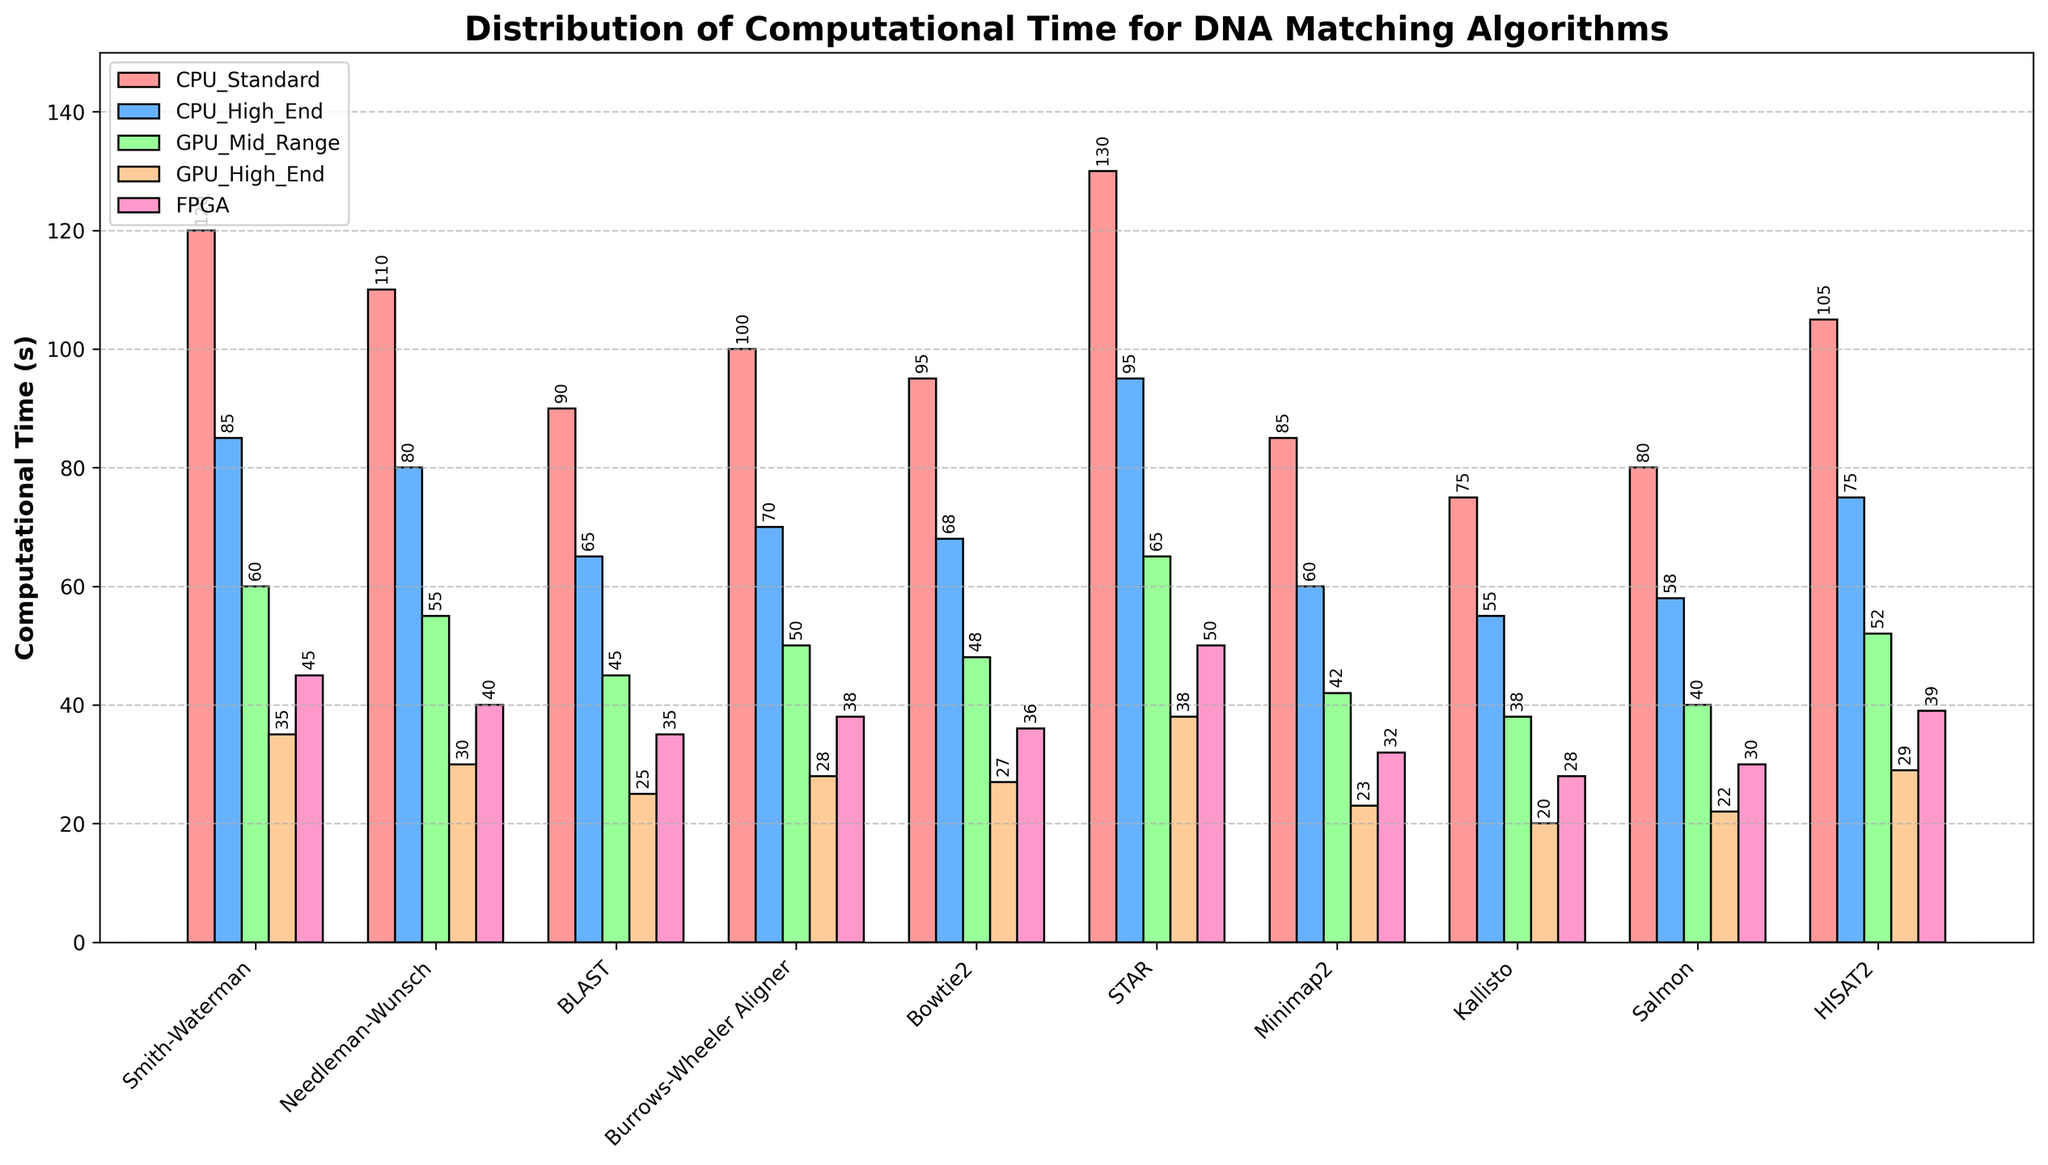Which algorithm has the highest computational time on GPU High-End hardware? By comparing the height of the bars for GPU High-End across all algorithms, we see that STAR has the tallest bar.
Answer: STAR Which algorithm shows the largest difference in computational time between CPU Standard and GPU High-End? By calculating the difference for each algorithm, the largest difference is with Smith-Waterman, which is 120 - 35 = 85 seconds.
Answer: Smith-Waterman What is the average computational time for BLAST across all hardware configurations? Sum the computational times for BLAST on all hardware (90 + 65 + 45 + 25 + 35) and divide by 5. The sum is 260, so the average is 260/5 = 52.
Answer: 52 What is the total computational time for the STAR algorithm on CPU High-End and FPGA? Sum the times on CPU High-End and FPGA for STAR: 95 + 50 = 145.
Answer: 145 Which combination of algorithm and hardware shows the lowest computational time? By locating the shortest bar across all algorithms and hardware, it is Kallisto on GPU High-End with a value of 20 seconds.
Answer: Kallisto on GPU High-End Which algorithm has less computational time on FPGA compared to CPU High-End? Compare the heights of the bars for FPGA and CPU High-End, observing which algorithms have taller bars for CPU High-End. These are Smith-Waterman, Needleman-Wunsch, Burrows-Wheeler Aligner, Bowtie2, Minimap2, Kallisto, Salmon, and HISAT2.
Answer: Smith-Waterman, Needleman-Wunsch, Burrows-Wheeler Aligner, Bowtie2, Minimap2, Kallisto, Salmon, HISAT2 How does the computational time of Minimap2 on GPU Mid-Range compare to BLAST on the same hardware? Compare the heights of the bars for Minimap2 and BLAST on GPU Mid-Range. Minimap2 has a value of 42 seconds and BLAST has 45 seconds. Minimap2 is less.
Answer: Minimap2 is less What is the difference in computational time between the highest and lowest values for Bowtie2 across hardware configurations? Identify the highest (95 on CPU Standard) and lowest (27 on GPU High-End) computational times for Bowtie2, then find the difference: 95 - 27 = 68 seconds.
Answer: 68 seconds Which hardware configuration typically gives the second fastest computational time across most algorithms? Analyzing the bars, GPU High-End generally has the fastest times, followed by FPGA for most algorithms.
Answer: FPGA How much faster is Kallisto on GPU High-End compared to CPU Standard? Subtract the GPU High-End time for Kallisto (20) from the CPU Standard time (75): 75 - 20 = 55 seconds.
Answer: 55 seconds 